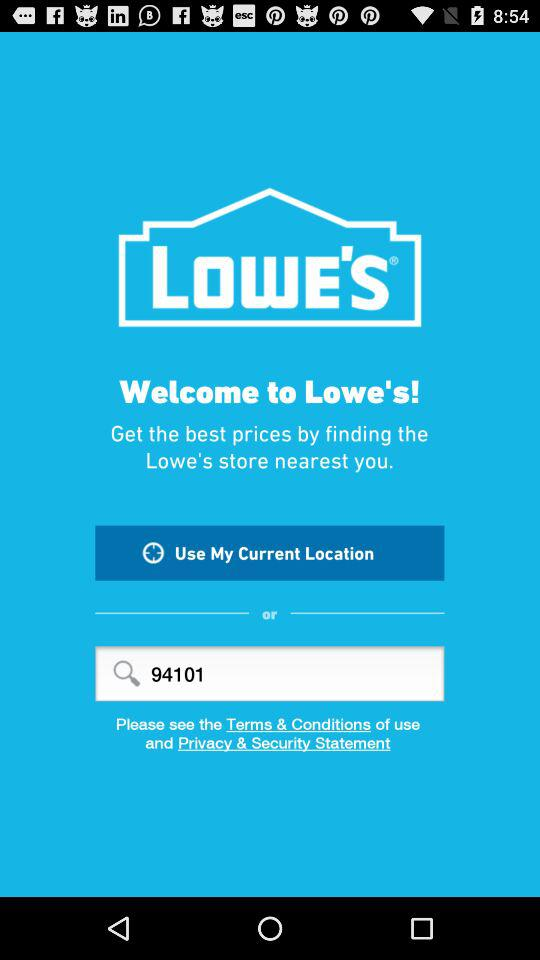What is the value input into the search bar? The value input into the search bar is 94101. 